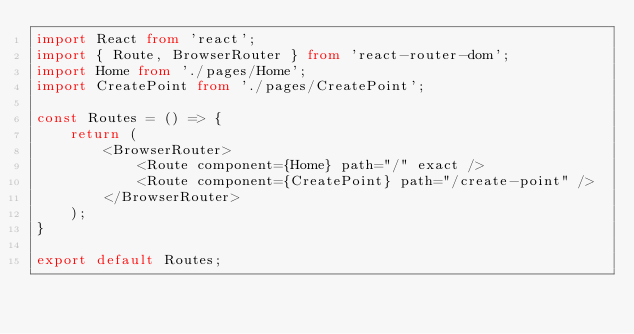Convert code to text. <code><loc_0><loc_0><loc_500><loc_500><_TypeScript_>import React from 'react';
import { Route, BrowserRouter } from 'react-router-dom';
import Home from './pages/Home';
import CreatePoint from './pages/CreatePoint';

const Routes = () => {
    return (
        <BrowserRouter>
            <Route component={Home} path="/" exact />
            <Route component={CreatePoint} path="/create-point" />
        </BrowserRouter>
    );
}

export default Routes;
</code> 